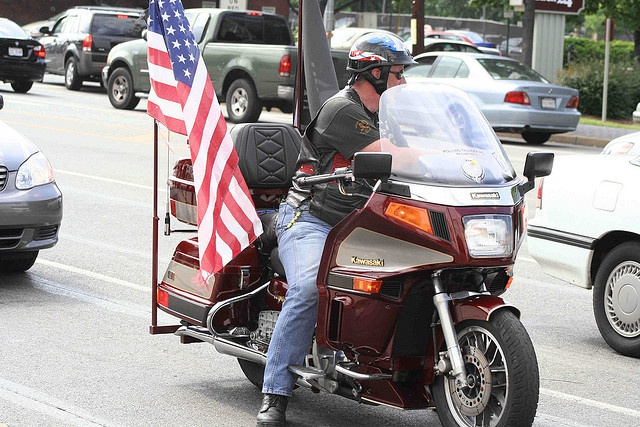Describe the objects in this image and their specific colors. I can see motorcycle in black, lightgray, gray, and darkgray tones, people in black, gray, lavender, and darkgray tones, car in black, white, gray, and darkgray tones, truck in black, gray, lightgray, and darkgray tones, and car in black, white, gray, and darkgray tones in this image. 